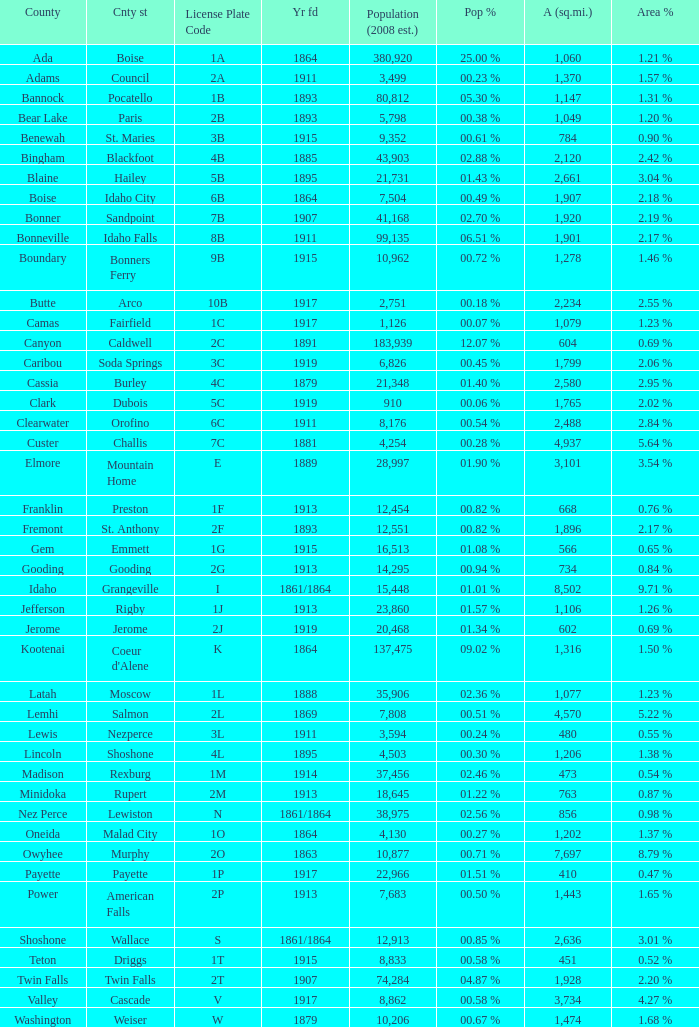What is the country seat for the license plate code 5c? Dubois. 